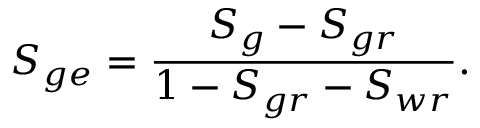Convert formula to latex. <formula><loc_0><loc_0><loc_500><loc_500>S _ { g e } = \frac { S _ { g } - S _ { g r } } { 1 - S _ { g r } - S _ { w r } } .</formula> 